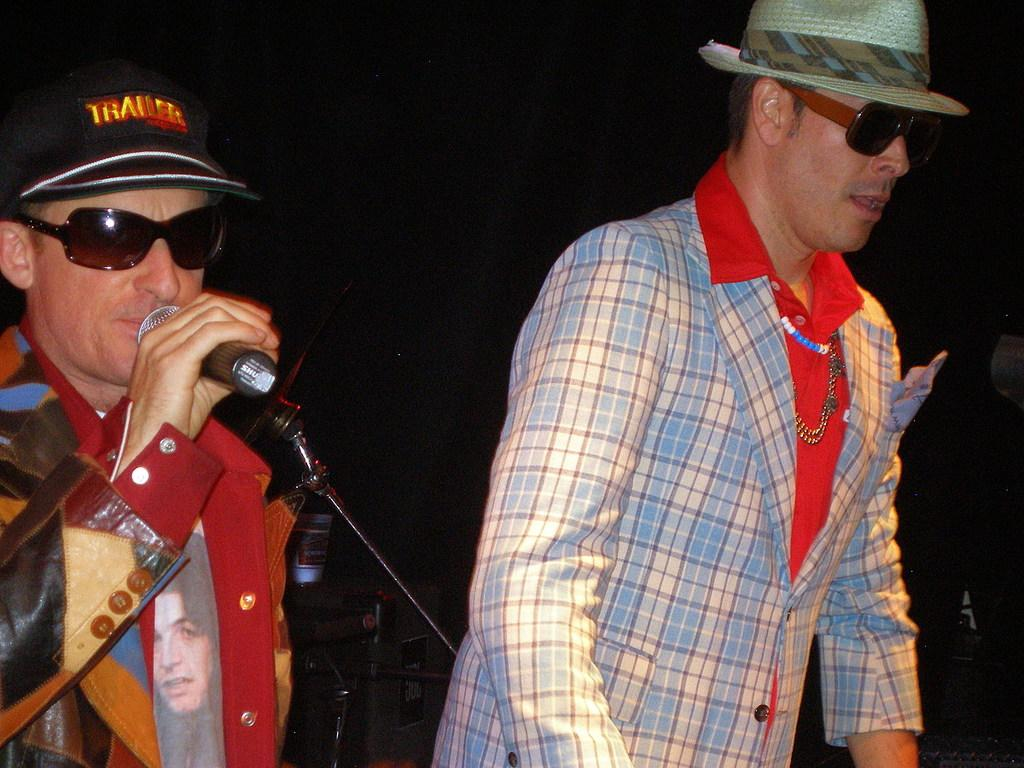How many people are in the image? There are two persons in the image. What is the person on the left doing? The person on the left is singing into a microphone. How is the person on the right dressed? The person on the right is wearing a blazer, cap, and goggles. What is the color of the background in the image? The background of the image is dark. What type of mass can be seen in the image? There is no mass present in the image; it features two people, one singing and the other wearing a blazer, cap, and goggles. Is there any mist visible in the image? There is no mist visible in the image; the background is dark. 